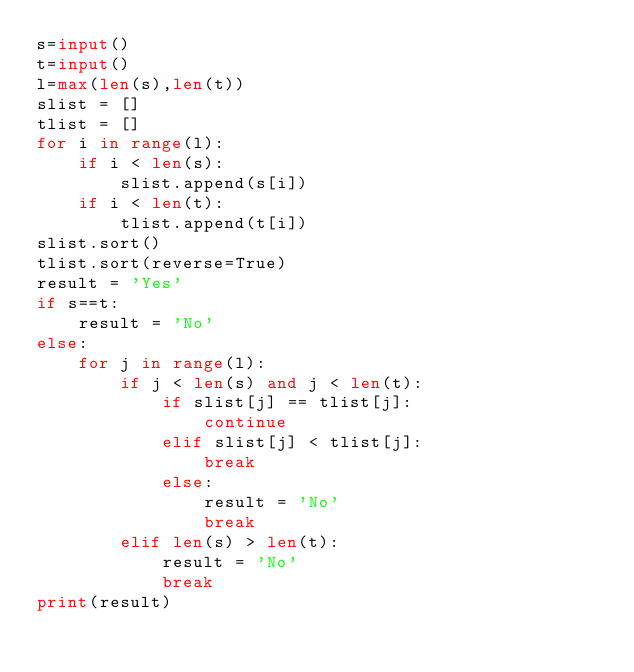Convert code to text. <code><loc_0><loc_0><loc_500><loc_500><_Python_>s=input()
t=input()
l=max(len(s),len(t))
slist = []
tlist = []
for i in range(l):
    if i < len(s):
        slist.append(s[i])
    if i < len(t):
        tlist.append(t[i])
slist.sort()
tlist.sort(reverse=True)
result = 'Yes'
if s==t:
    result = 'No'
else:
    for j in range(l):
        if j < len(s) and j < len(t):
            if slist[j] == tlist[j]:
                continue
            elif slist[j] < tlist[j]:
                break
            else:
                result = 'No'
                break
        elif len(s) > len(t):
            result = 'No'
            break
print(result)</code> 